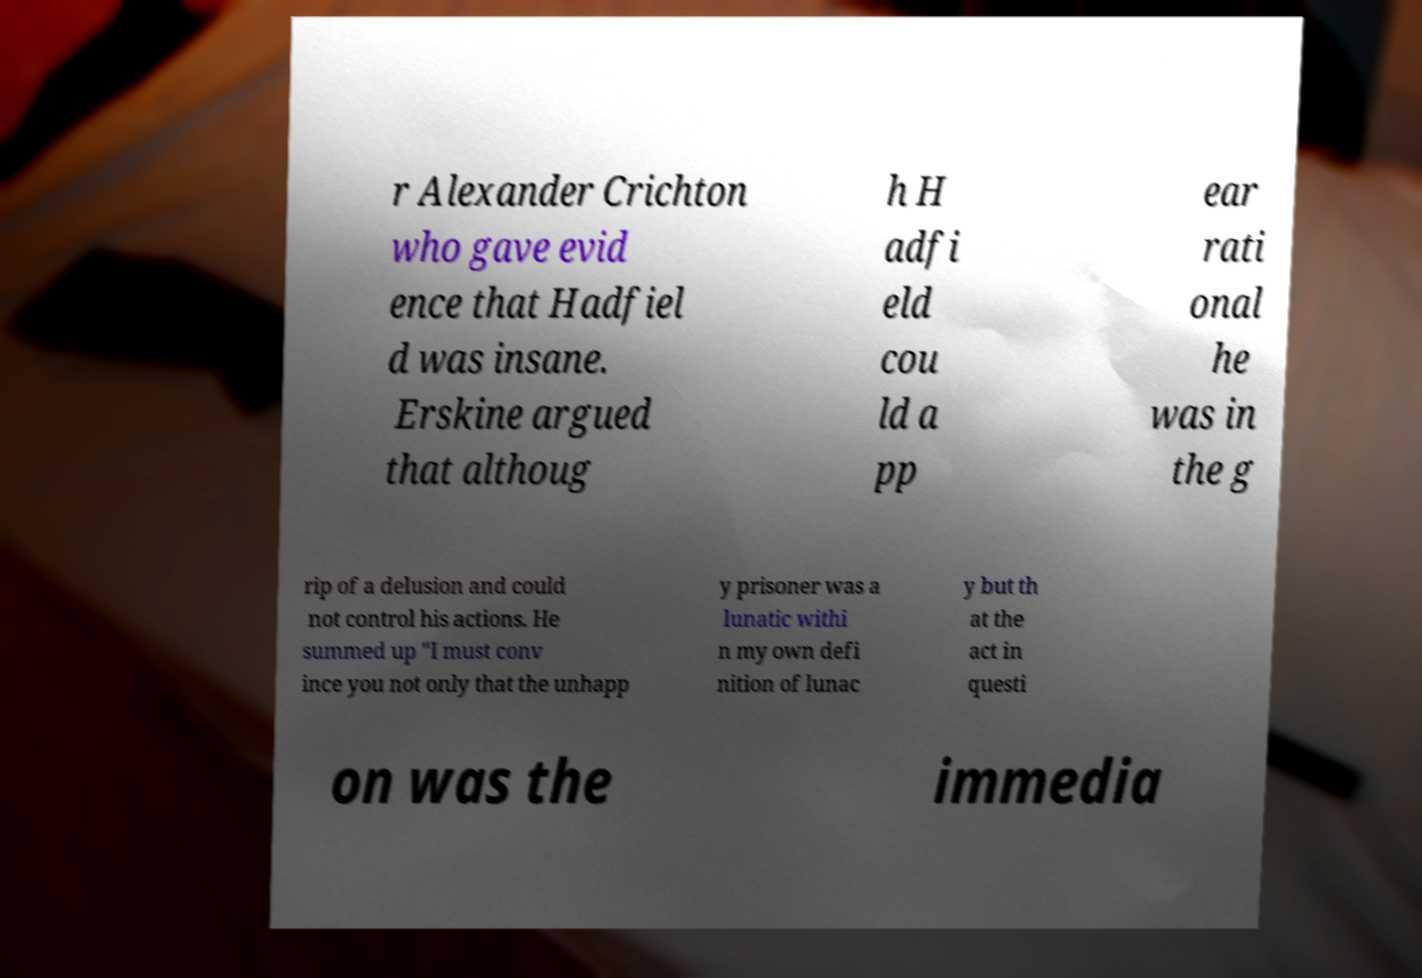What messages or text are displayed in this image? I need them in a readable, typed format. r Alexander Crichton who gave evid ence that Hadfiel d was insane. Erskine argued that althoug h H adfi eld cou ld a pp ear rati onal he was in the g rip of a delusion and could not control his actions. He summed up "I must conv ince you not only that the unhapp y prisoner was a lunatic withi n my own defi nition of lunac y but th at the act in questi on was the immedia 